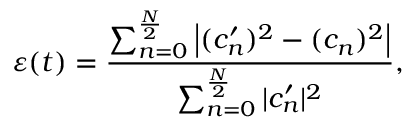<formula> <loc_0><loc_0><loc_500><loc_500>\varepsilon ( t ) = \frac { \sum _ { n = 0 } ^ { \frac { N } { 2 } } \left | ( c _ { n } ^ { \prime } ) ^ { 2 } - ( c _ { n } ) ^ { 2 } \right | } { \sum _ { n = 0 } ^ { \frac { N } { 2 } } | c _ { n } ^ { \prime } | ^ { 2 } } ,</formula> 